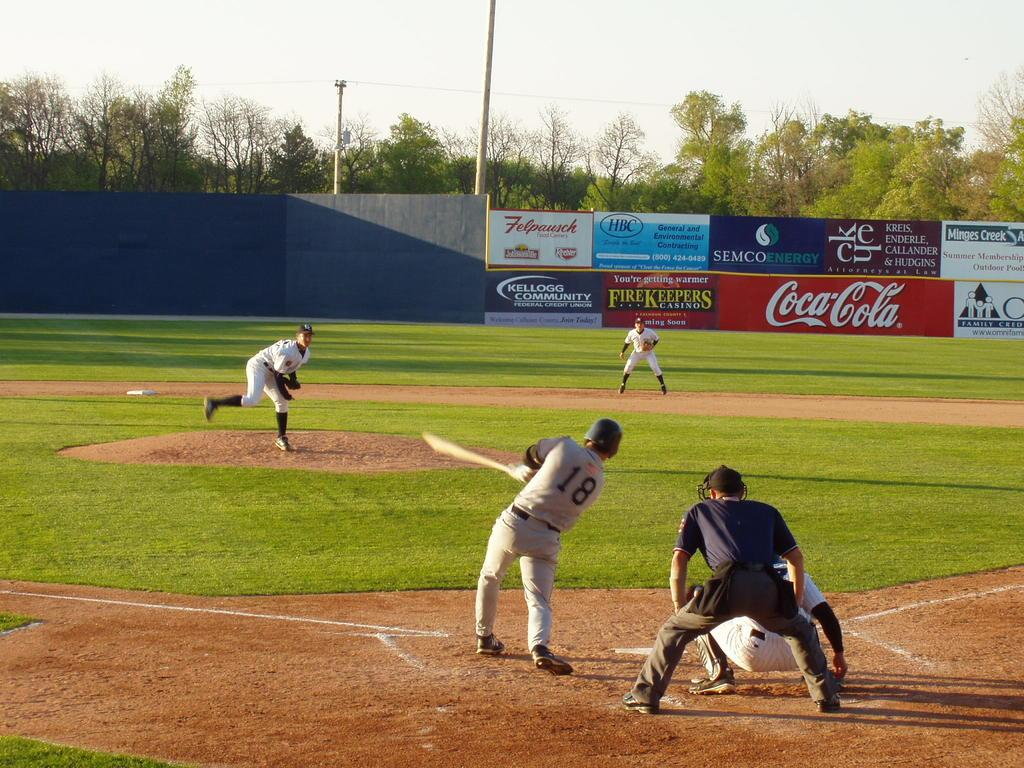<image>
Relay a brief, clear account of the picture shown. Player number 18 on the baseball field swings his bat to hit the ball while a player near the CocaCola ad gets ready to catch it 